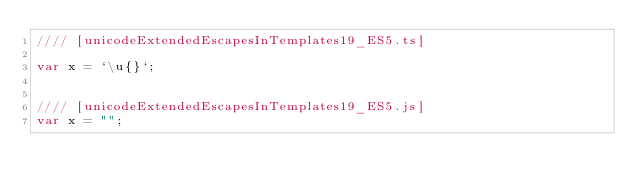<code> <loc_0><loc_0><loc_500><loc_500><_JavaScript_>//// [unicodeExtendedEscapesInTemplates19_ES5.ts]

var x = `\u{}`;


//// [unicodeExtendedEscapesInTemplates19_ES5.js]
var x = "";
</code> 